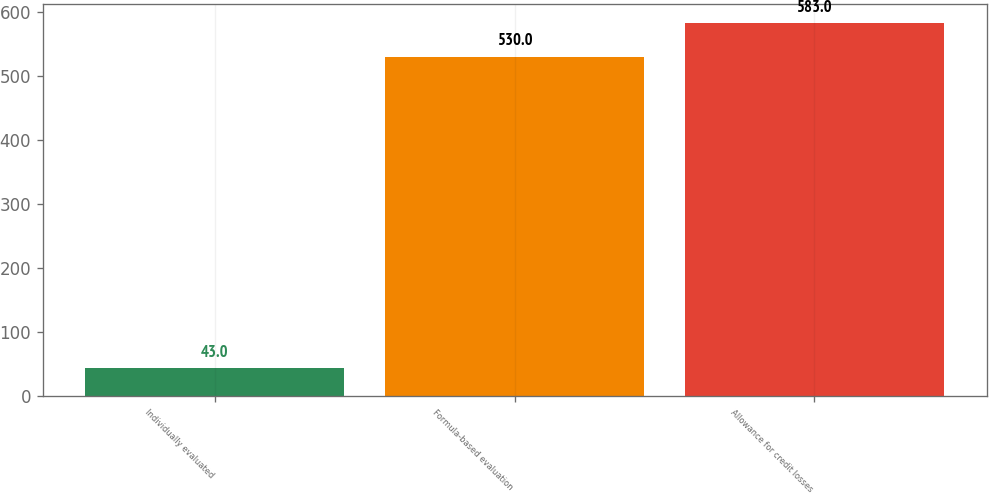Convert chart. <chart><loc_0><loc_0><loc_500><loc_500><bar_chart><fcel>Individually evaluated<fcel>Formula-based evaluation<fcel>Allowance for credit losses<nl><fcel>43<fcel>530<fcel>583<nl></chart> 